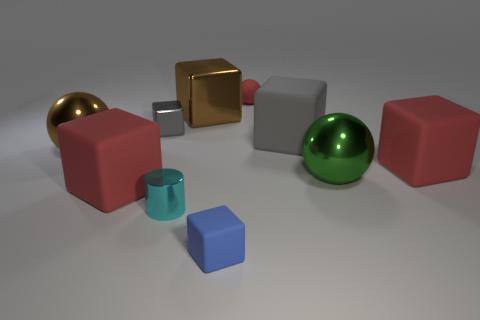Subtract all green cylinders. How many red cubes are left? 2 Subtract all tiny red spheres. How many spheres are left? 2 Subtract all red cubes. How many cubes are left? 4 Subtract 1 blocks. How many blocks are left? 5 Add 1 tiny purple blocks. How many tiny purple blocks exist? 1 Subtract 0 blue balls. How many objects are left? 10 Subtract all cylinders. How many objects are left? 9 Subtract all gray balls. Subtract all brown blocks. How many balls are left? 3 Subtract all small cubes. Subtract all small objects. How many objects are left? 4 Add 6 small metallic things. How many small metallic things are left? 8 